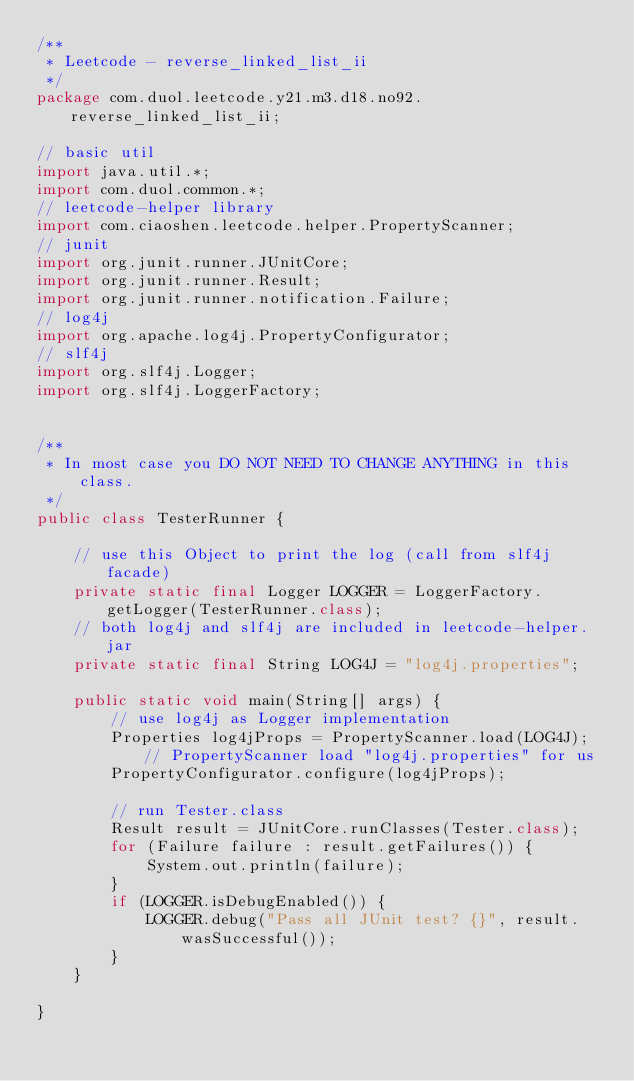<code> <loc_0><loc_0><loc_500><loc_500><_Java_>/**
 * Leetcode - reverse_linked_list_ii
 */
package com.duol.leetcode.y21.m3.d18.no92.reverse_linked_list_ii;

// basic util
import java.util.*;
import com.duol.common.*;
// leetcode-helper library
import com.ciaoshen.leetcode.helper.PropertyScanner;
// junit 
import org.junit.runner.JUnitCore;
import org.junit.runner.Result;
import org.junit.runner.notification.Failure;
// log4j
import org.apache.log4j.PropertyConfigurator;
// slf4j
import org.slf4j.Logger;
import org.slf4j.LoggerFactory;


/**
 * In most case you DO NOT NEED TO CHANGE ANYTHING in this class.
 */
public class TesterRunner {

    // use this Object to print the log (call from slf4j facade)
    private static final Logger LOGGER = LoggerFactory.getLogger(TesterRunner.class);
    // both log4j and slf4j are included in leetcode-helper.jar
    private static final String LOG4J = "log4j.properties";

    public static void main(String[] args) {
        // use log4j as Logger implementation
        Properties log4jProps = PropertyScanner.load(LOG4J); // PropertyScanner load "log4j.properties" for us
        PropertyConfigurator.configure(log4jProps);

        // run Tester.class
        Result result = JUnitCore.runClasses(Tester.class);
        for (Failure failure : result.getFailures()) {
            System.out.println(failure);
        }
        if (LOGGER.isDebugEnabled()) {
            LOGGER.debug("Pass all JUnit test? {}", result.wasSuccessful());
        }
    }

}
</code> 